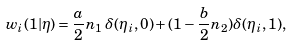<formula> <loc_0><loc_0><loc_500><loc_500>w _ { i } ( 1 | \eta ) = \frac { a } 2 n _ { 1 } \, \delta ( \eta _ { i } , 0 ) + ( 1 - \frac { b } 2 n _ { 2 } ) \delta ( \eta _ { i } , 1 ) ,</formula> 